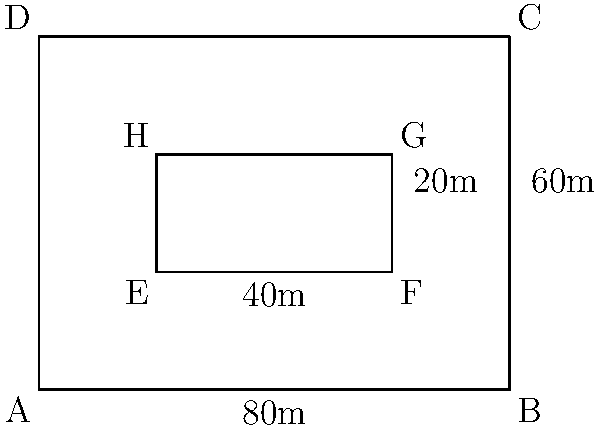As a community organizer planning a protest, you've received an aerial image of the designated gathering area. The image shows a rectangular space with dimensions 80m by 60m. Within this area, there's a smaller rectangular space reserved for speakers and equipment, measuring 40m by 20m. Calculate the area available for protesters, excluding the reserved space. To solve this problem, we'll follow these steps:

1. Calculate the total area of the gathering space:
   $A_{total} = 80m \times 60m = 4800m^2$

2. Calculate the area of the reserved space:
   $A_{reserved} = 40m \times 20m = 800m^2$

3. Subtract the reserved area from the total area to get the space available for protesters:
   $A_{protesters} = A_{total} - A_{reserved}$
   $A_{protesters} = 4800m^2 - 800m^2 = 4000m^2$

Therefore, the area available for protesters is $4000m^2$.
Answer: $4000m^2$ 